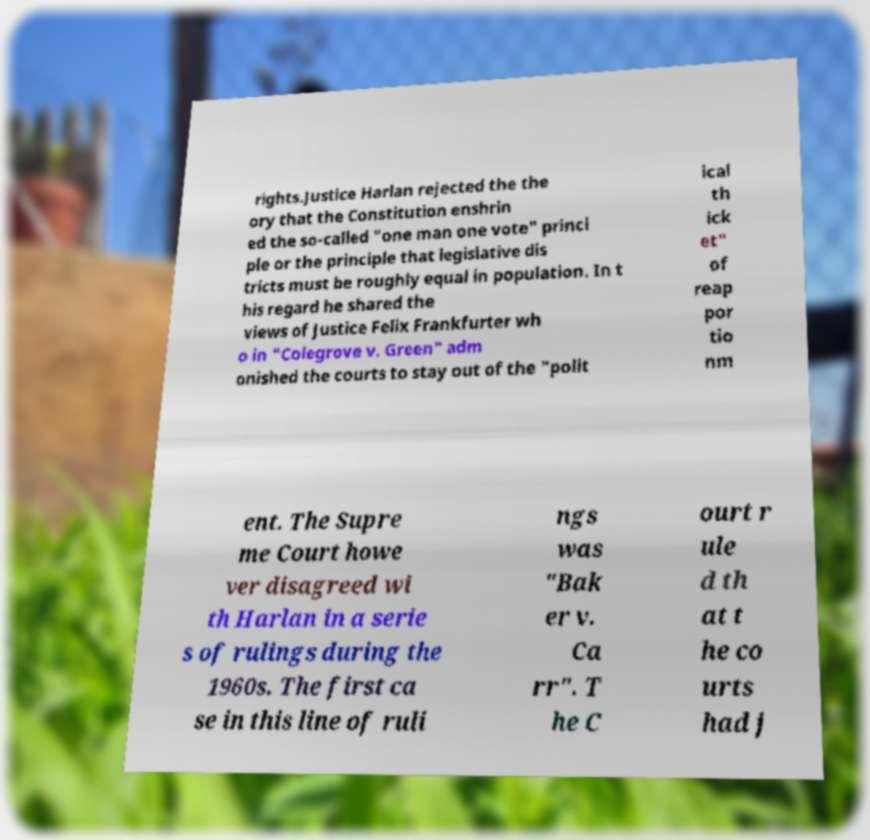What messages or text are displayed in this image? I need them in a readable, typed format. rights.Justice Harlan rejected the the ory that the Constitution enshrin ed the so-called "one man one vote" princi ple or the principle that legislative dis tricts must be roughly equal in population. In t his regard he shared the views of Justice Felix Frankfurter wh o in "Colegrove v. Green" adm onished the courts to stay out of the "polit ical th ick et" of reap por tio nm ent. The Supre me Court howe ver disagreed wi th Harlan in a serie s of rulings during the 1960s. The first ca se in this line of ruli ngs was "Bak er v. Ca rr". T he C ourt r ule d th at t he co urts had j 